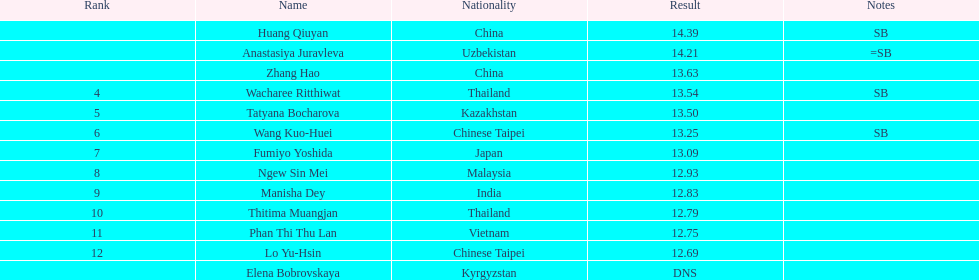Parse the full table. {'header': ['Rank', 'Name', 'Nationality', 'Result', 'Notes'], 'rows': [['', 'Huang Qiuyan', 'China', '14.39', 'SB'], ['', 'Anastasiya Juravleva', 'Uzbekistan', '14.21', '=SB'], ['', 'Zhang Hao', 'China', '13.63', ''], ['4', 'Wacharee Ritthiwat', 'Thailand', '13.54', 'SB'], ['5', 'Tatyana Bocharova', 'Kazakhstan', '13.50', ''], ['6', 'Wang Kuo-Huei', 'Chinese Taipei', '13.25', 'SB'], ['7', 'Fumiyo Yoshida', 'Japan', '13.09', ''], ['8', 'Ngew Sin Mei', 'Malaysia', '12.93', ''], ['9', 'Manisha Dey', 'India', '12.83', ''], ['10', 'Thitima Muangjan', 'Thailand', '12.79', ''], ['11', 'Phan Thi Thu Lan', 'Vietnam', '12.75', ''], ['12', 'Lo Yu-Hsin', 'Chinese Taipei', '12.69', ''], ['', 'Elena Bobrovskaya', 'Kyrgyzstan', 'DNS', '']]} What was the typical score for the three leading jumpers? 14.08. 